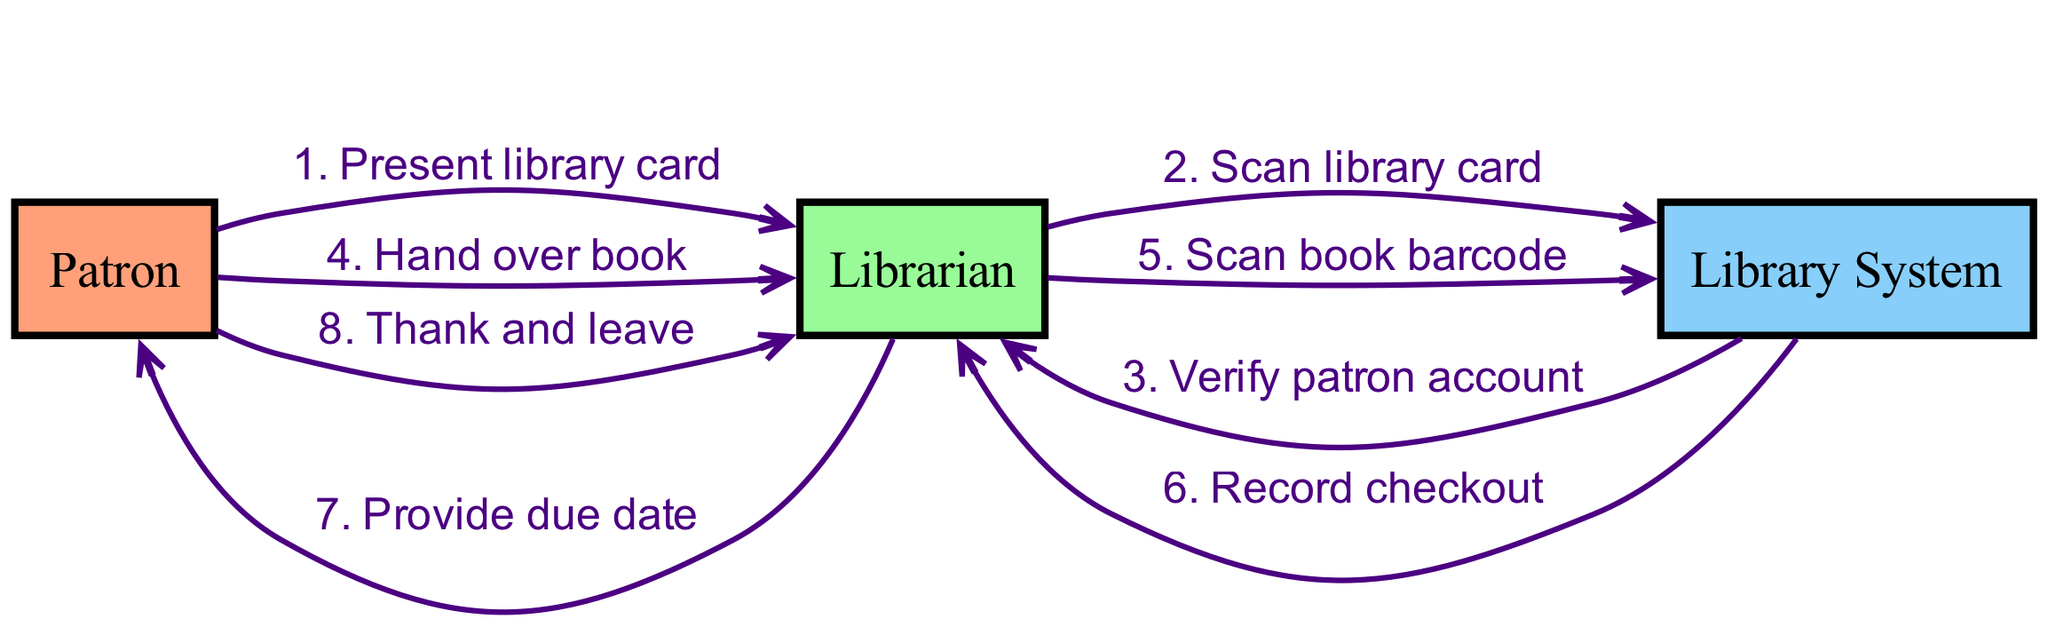What is the first action taken by the Patron? The first action in the sequence diagram indicates that the Patron presents their library card to the Librarian. This is the initial step in the checkout process.
Answer: Present library card How many actors are involved in the checkout process? The diagram presents a total of three actors involved in the process: the Patron, the Librarian, and the Library System. This is determined by counting the distinct roles present in the diagram.
Answer: Three Who scans the library card? The Librarian is the one who scans the library card as indicated in the sequence where the message to scan is sent from the Librarian to the Library System.
Answer: Librarian What message does the Library System send back to the Librarian after scanning the library card? After the Librarian scans the library card, the Library System verifies the patron account and sends this verification back to the Librarian as indicated in the next step of the sequence.
Answer: Verify patron account What is the last action of the sequence? The last action in the sequence shows the Patron thanking the Librarian and leaving, marking the conclusion of the book checkout process as depicted at the end of the steps.
Answer: Thank and leave What message does the Librarian provide to the Patron during the checkout process? During the checkout process, the Librarian provides the Patron with the due date. This communication occurs after recording the checkout in the sequence of events.
Answer: Provide due date Which two actors interact when "Hand over book" occurs? The "Hand over book" action involves interaction between the Patron and the Librarian, as this step explicitly describes the Patron handing the book to the Librarian.
Answer: Patron and Librarian How many steps are there in the checkout sequence? The checkout sequence consists of a total of eight steps, which are outlined as individual interactions between the actors, and can be counted from the sequence list provided.
Answer: Eight 